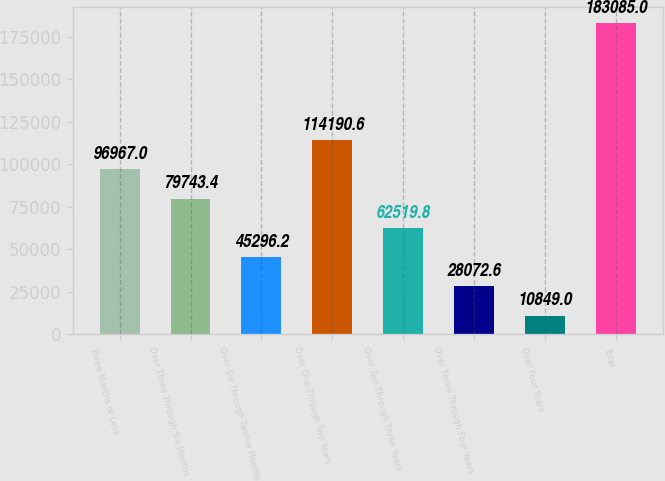Convert chart. <chart><loc_0><loc_0><loc_500><loc_500><bar_chart><fcel>Three Months or Less<fcel>Over Three Through Six Months<fcel>Over Six Through Twelve Months<fcel>Over One Through Two Years<fcel>Over Two Through Three Years<fcel>Over Three Through Four Years<fcel>Over Four Years<fcel>Total<nl><fcel>96967<fcel>79743.4<fcel>45296.2<fcel>114191<fcel>62519.8<fcel>28072.6<fcel>10849<fcel>183085<nl></chart> 